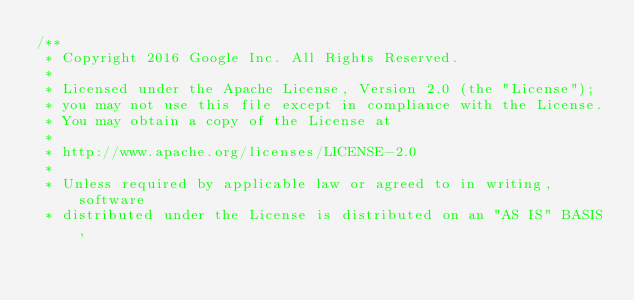<code> <loc_0><loc_0><loc_500><loc_500><_Java_>/**
 * Copyright 2016 Google Inc. All Rights Reserved.
 *
 * Licensed under the Apache License, Version 2.0 (the "License");
 * you may not use this file except in compliance with the License.
 * You may obtain a copy of the License at
 *
 * http://www.apache.org/licenses/LICENSE-2.0
 *
 * Unless required by applicable law or agreed to in writing, software
 * distributed under the License is distributed on an "AS IS" BASIS,</code> 